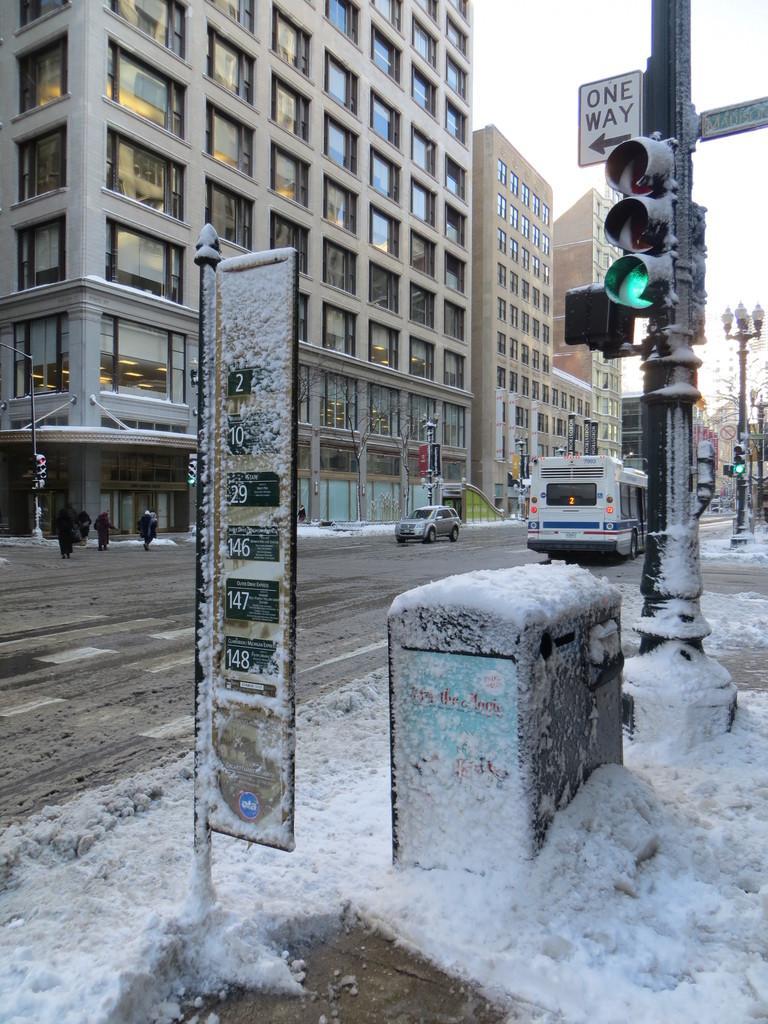Please provide a concise description of this image. This is the picture of a road. In the foreground there are poles on the footpath and there are boards and lights on the poles. At the back there are vehicles on the road and there are group of people walking on the road. There are buildings and trees. At the top there is sky. At the bottom there is a road and there is snow. 